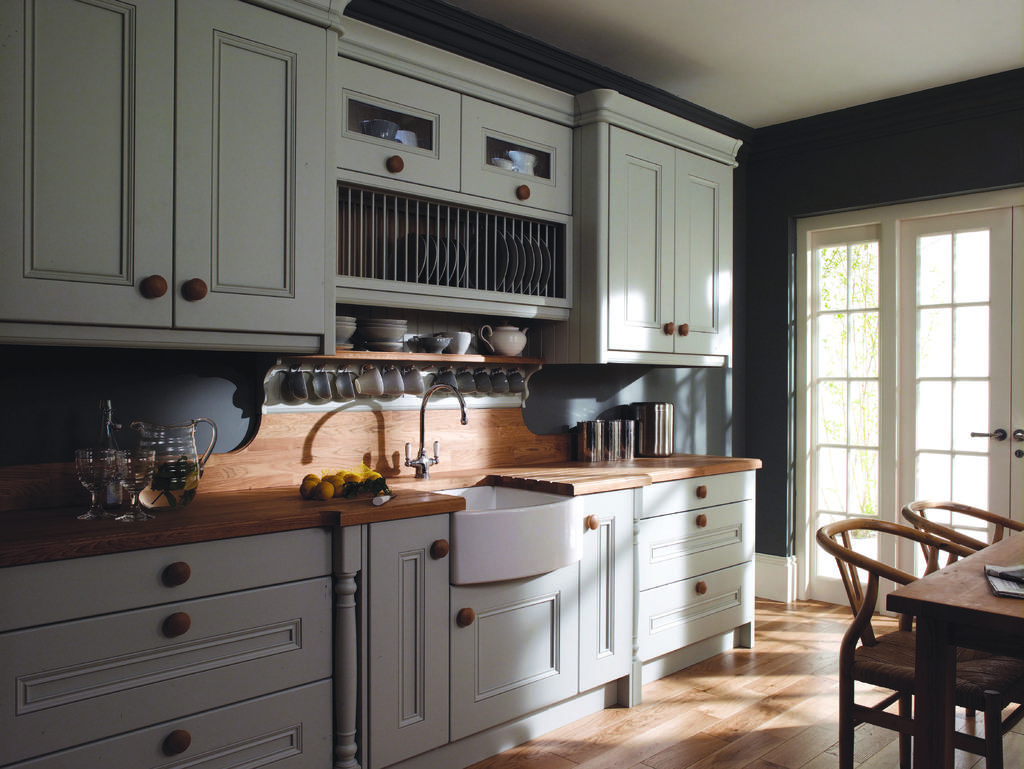What type of furniture is present in the image? There is a cupboard and a kitchen table in the image. How many chairs are visible in the image? There are four chairs in the image. What else can be seen on the kitchen table? There are other objects on the kitchen table. Can you see a nest on top of the cupboard in the image? There is no nest present on top of the cupboard in the image. 